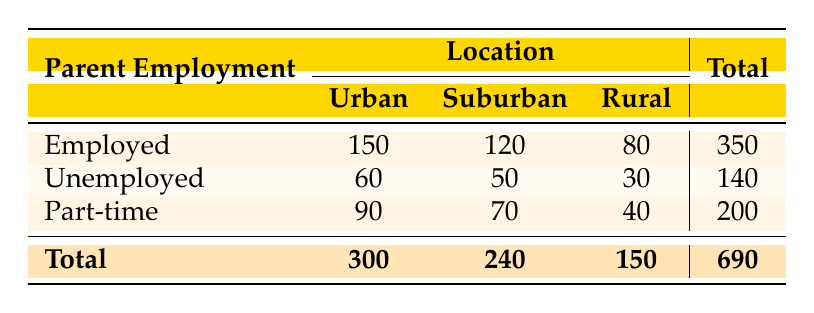What is the total attendance for children with employed parents living in suburban areas? According to the table, the attendance count for employed parents in suburban locations is 120.
Answer: 120 What is the attendance count for children whose parents are unemployed and live in rural areas? The table shows that the attendance count for unemployed parents in rural areas is 30.
Answer: 30 How many total students attended school from rural areas in the employed group? The table lists the attendance for employed parents in rural areas as 80.
Answer: 80 What is the average attendance count for employed parents across all locations? To find the average attendance count for employed parents, we sum their attendance counts (150 + 120 + 80 = 350) and divide by the number of locations (3). Thus, the average is 350 / 3 ≈ 116.67.
Answer: Approximately 116.67 Is there a higher total attendance for children with part-time working parents in urban areas compared to those with unemployed parents in suburban areas? The attendance count for part-time parents in urban areas is 90, while for unemployed parents in suburban areas, it is 50. Since 90 is greater than 50, the statement is true.
Answer: Yes What is the total attendance count from the urban locations for all employment statuses? The total attendance for urban locations is calculated by adding all urban attendance counts: (150 + 60 + 90 = 300).
Answer: 300 What percentage of total attendance comes from children with employed parents? The total attendance count is 690 (from the grand total), and employed parents account for 350 of that. The percentage is (350 / 690) * 100 ≈ 50.72%.
Answer: Approximately 50.72% If you combine the attendance numbers for part-time and employed parents in suburban areas, what is the resulting total? For part-time parents in suburban areas, the attendance count is 70, and for employed parents, it's 120. Adding them together gives us (120 + 70 = 190).
Answer: 190 Is the attendance count for children with unemployed parents in urban areas less than those with part-time employment in rural areas? The count for unemployed parents in urban is 60, while for part-time parents in rural is 40. Since 60 is greater than 40, the statement is false.
Answer: No 